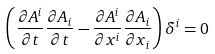Convert formula to latex. <formula><loc_0><loc_0><loc_500><loc_500>\left ( \frac { \partial A ^ { i } } { \partial t } \frac { \partial A _ { i } } { \partial t } - \frac { \partial A ^ { i } } { \partial x ^ { i } } \frac { \partial A _ { i } } { \partial x _ { i } } \right ) \delta ^ { i } = 0</formula> 